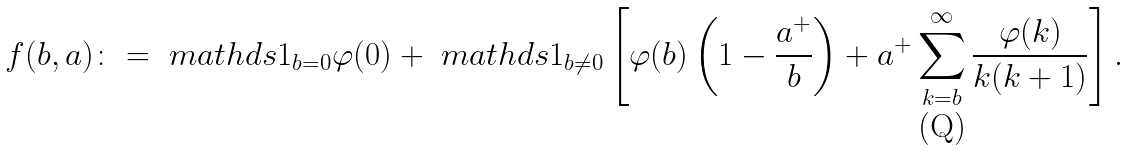<formula> <loc_0><loc_0><loc_500><loc_500>f ( b , a ) \colon = \ m a t h d s { 1 } _ { b = 0 } \varphi ( 0 ) + \ m a t h d s { 1 } _ { b \neq 0 } \left [ \varphi ( b ) \left ( 1 - \frac { a ^ { + } } { b } \right ) + a ^ { + } \sum _ { k = b } ^ { \infty } \frac { \varphi ( k ) } { k ( k + 1 ) } \right ] .</formula> 